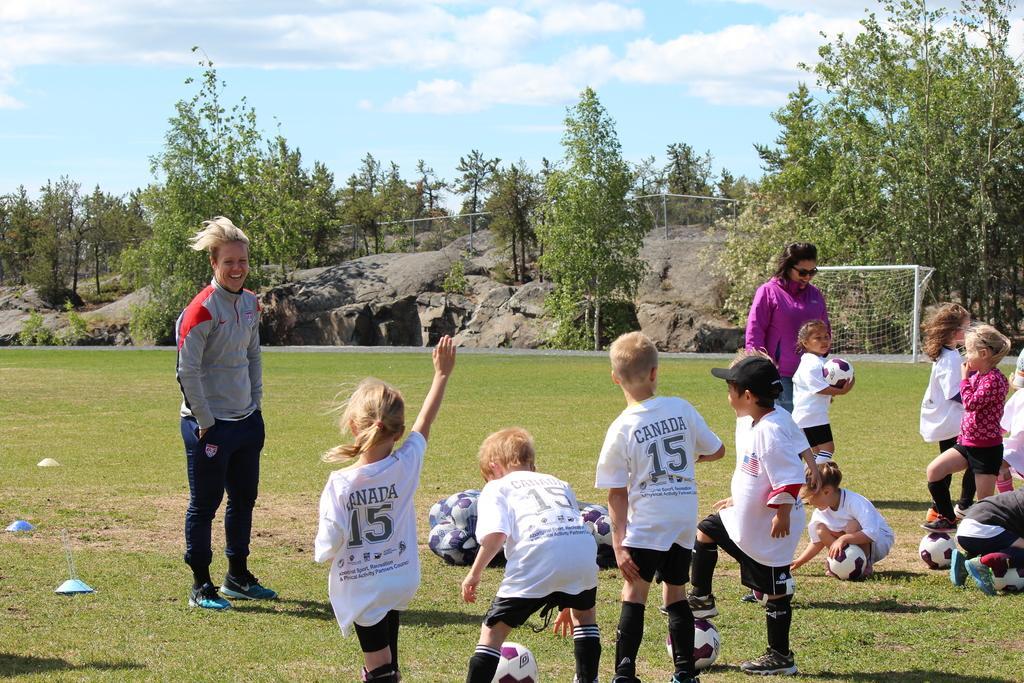Please provide a concise description of this image. In this image we can see a group of persons and footballs. Behind the persons we can see a goal post, rocks and a group of trees. At the top we can see the sky. 